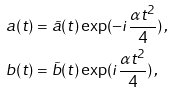<formula> <loc_0><loc_0><loc_500><loc_500>a ( t ) & = \tilde { a } ( t ) \exp ( - i \frac { \alpha t ^ { 2 } } { 4 } ) \, , \\ b ( t ) & = \tilde { b } ( t ) \exp ( i \frac { \alpha t ^ { 2 } } { 4 } ) \, ,</formula> 